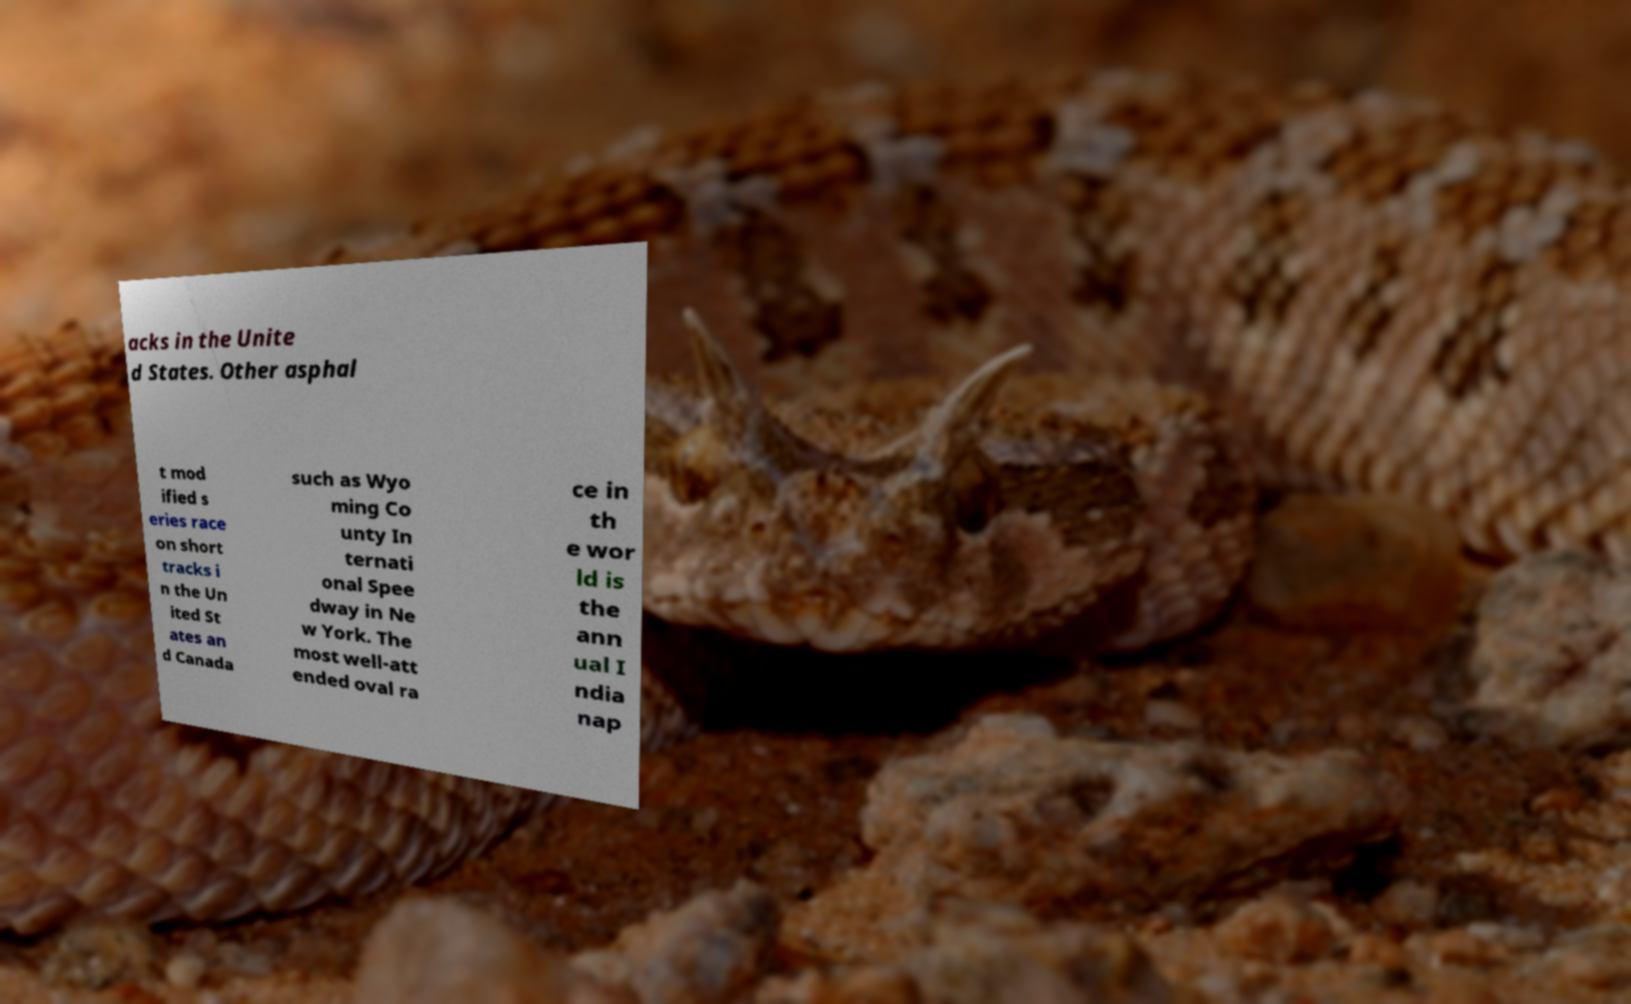Could you extract and type out the text from this image? acks in the Unite d States. Other asphal t mod ified s eries race on short tracks i n the Un ited St ates an d Canada such as Wyo ming Co unty In ternati onal Spee dway in Ne w York. The most well-att ended oval ra ce in th e wor ld is the ann ual I ndia nap 